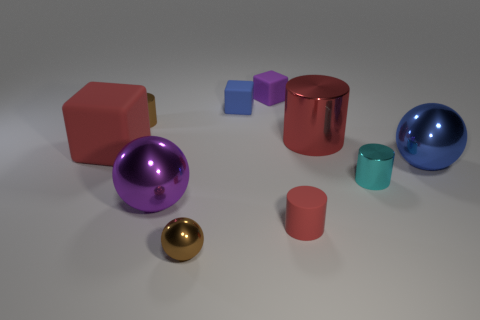What is the color of the tiny shiny ball on the left side of the tiny metal cylinder on the right side of the tiny brown metallic cylinder?
Offer a very short reply. Brown. What number of other objects are there of the same material as the purple cube?
Your answer should be compact. 3. What number of shiny objects are either blue objects or big things?
Provide a succinct answer. 3. There is another small rubber object that is the same shape as the purple matte object; what color is it?
Your answer should be very brief. Blue. How many things are either red matte cubes or cylinders?
Your answer should be very brief. 5. There is a large red thing that is made of the same material as the small purple cube; what is its shape?
Ensure brevity in your answer.  Cube. How many small things are red balls or blue metallic things?
Your answer should be compact. 0. What number of other objects are there of the same color as the big shiny cylinder?
Offer a very short reply. 2. What number of brown shiny objects are behind the brown shiny thing right of the small brown shiny thing that is behind the large red cylinder?
Make the answer very short. 1. Is the size of the brown thing that is in front of the red metallic cylinder the same as the small blue rubber object?
Your response must be concise. Yes. 